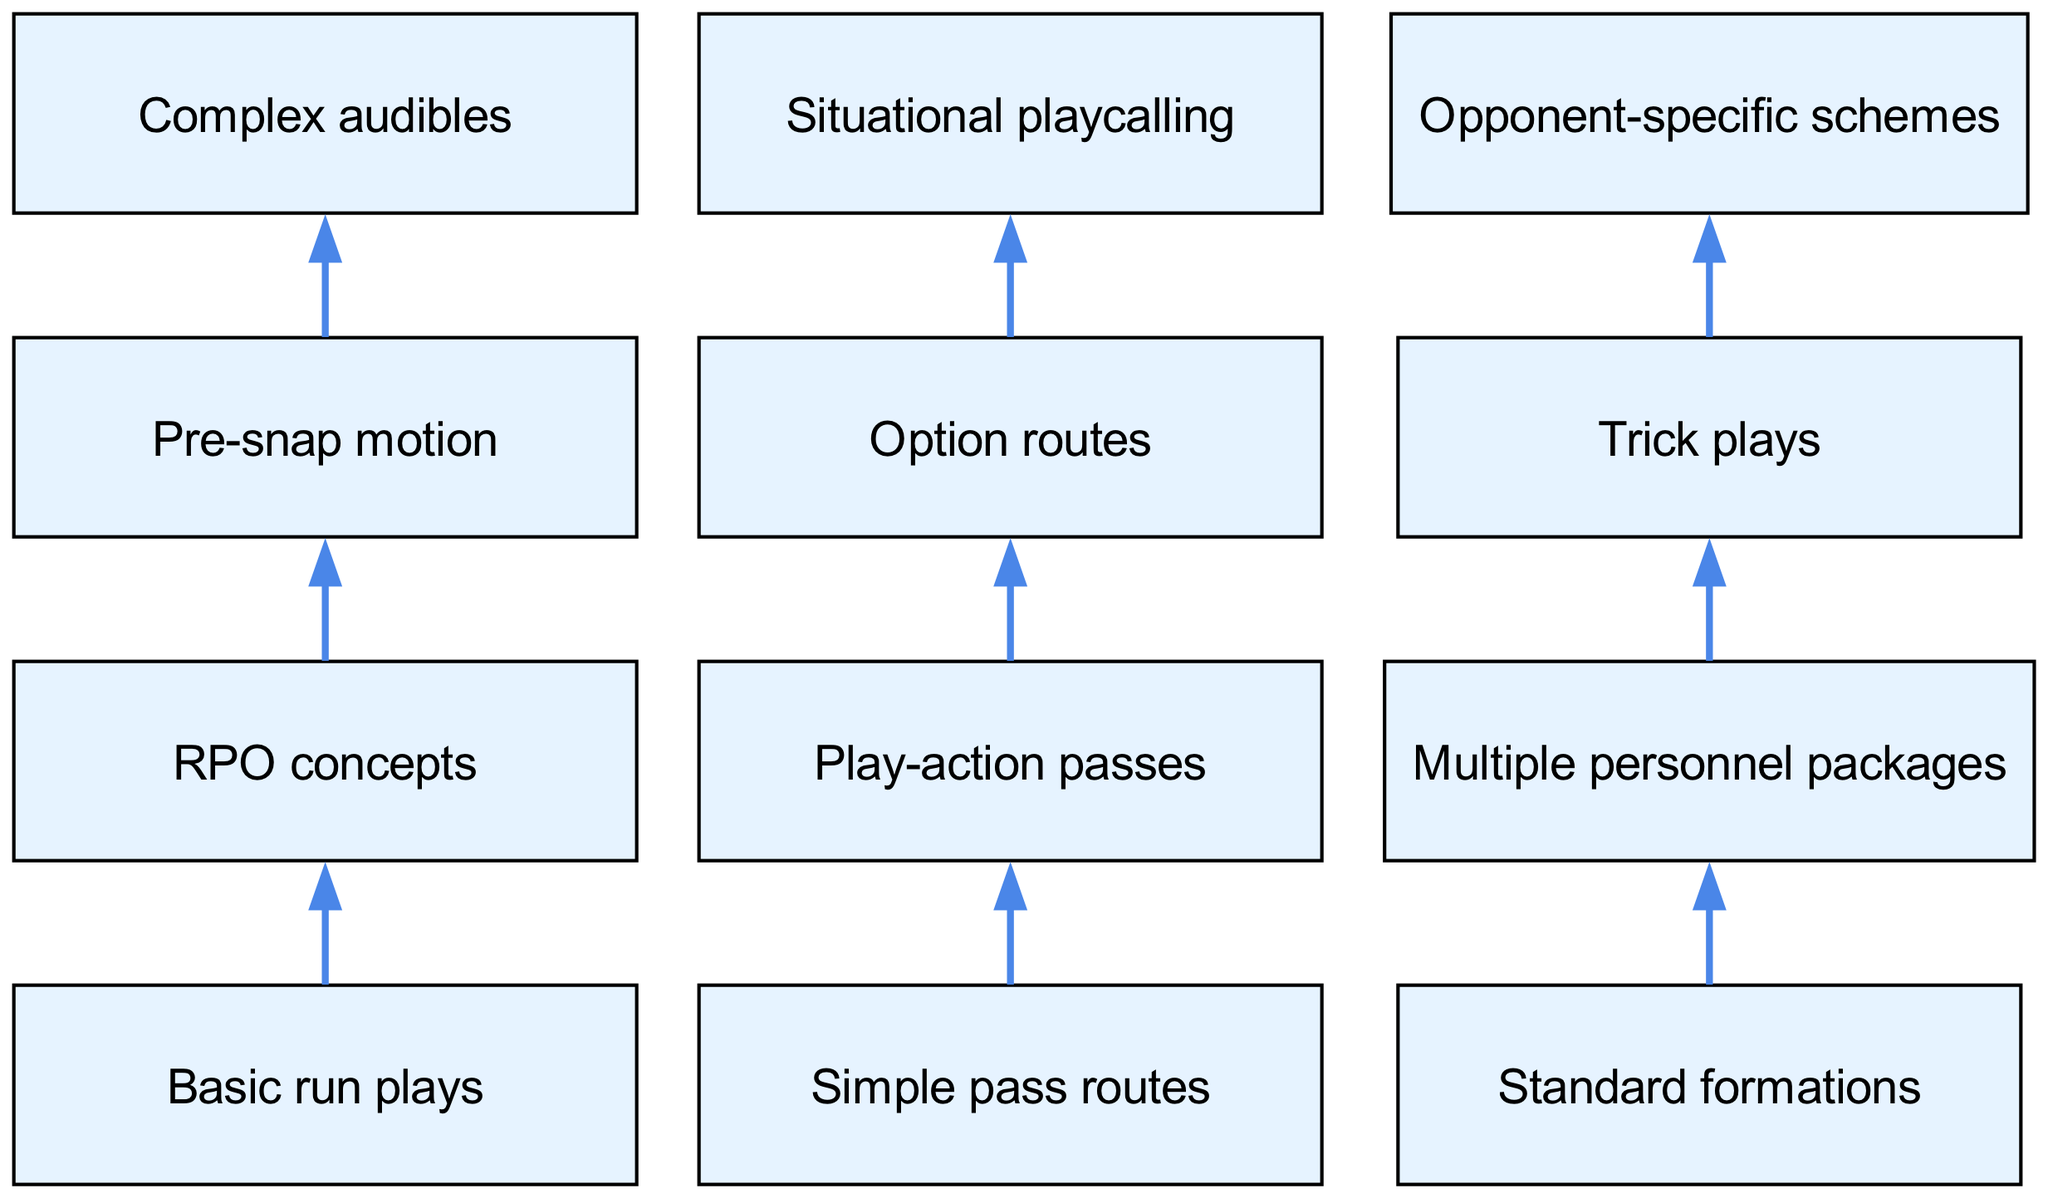What are the three items at level 1? The diagram indicates that level 1 consists of basic run plays, simple pass routes, and standard formations. This can be confirmed by locating the first level in the flow chart and examining the items listed there.
Answer: Basic run plays, simple pass routes, standard formations How many items are at level 3? From the diagram, level 3 contains three items, which are pre-snap motion, option routes, and trick plays. Counting the items listed under level 3 confirms this.
Answer: 3 What connects to situational playcalling? The diagram shows that situational playcalling is connected to option routes. By following the arrows from level 3 to level 4, we see that option routes point directly to situational playcalling.
Answer: Option routes What follows after multiple personnel packages? According to the connections in the diagram, multiple personnel packages are followed by trick plays. This can be deduced by tracing the arrow leading from multiple personnel packages to trick plays.
Answer: Trick plays Which item is the most complex in terms of connections? By analyzing the diagram, opponent-specific schemes appears to be the most complex because it is the final item in level 4 and is reached through multiple connections: it is preceded by trick plays. This means it has at least one direct preceding item.
Answer: Opponent-specific schemes What are the first two connections in the chart? The first two connections in the diagram link basic run plays to RPO concepts, and simple pass routes to play-action passes. By tracing the first two arrows in the flow chart, we can see these relationships.
Answer: Basic run plays to RPO concepts, simple pass routes to play-action passes How many total edges (connections) are present in the diagram? By counting the arrows (edges) in the diagram, one can find that there are a total of nine connections between nodes. These edges represent the relationships and transitions between various plays.
Answer: 9 What item leads to complex audibles? In the diagram, pre-snap motion leads to complex audibles. This is determined by identifying the connection that points from pre-snap motion to complex audibles.
Answer: Pre-snap motion Which level introduces trick plays into the sequence? Trick plays are introduced at level 3, where they are grouped with pre-snap motion and option routes. By identifying the structure of the flow chart and locating where trick plays appear, we conclude its level.
Answer: Level 3 